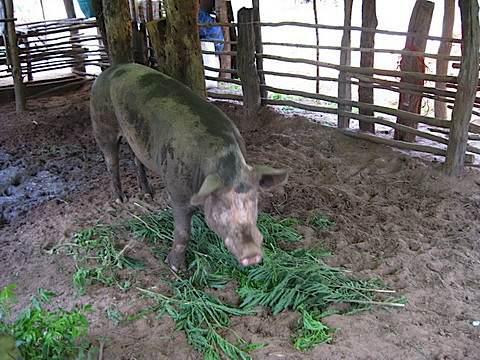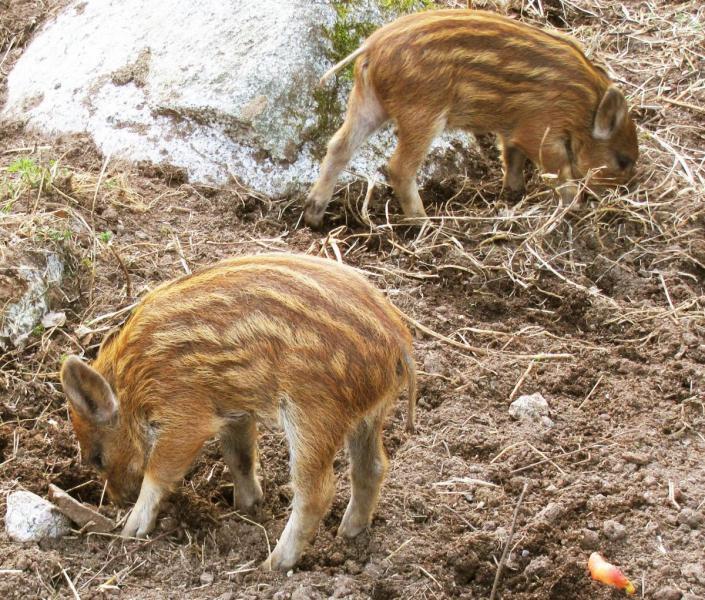The first image is the image on the left, the second image is the image on the right. Assess this claim about the two images: "In one image there is multiple striped pigs.". Correct or not? Answer yes or no. Yes. The first image is the image on the left, the second image is the image on the right. Considering the images on both sides, is "there are at most 3 pigs in the image pair" valid? Answer yes or no. Yes. 